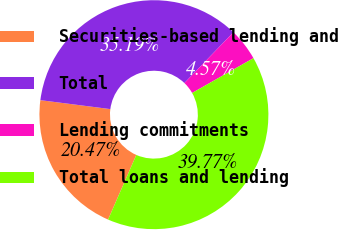Convert chart to OTSL. <chart><loc_0><loc_0><loc_500><loc_500><pie_chart><fcel>Securities-based lending and<fcel>Total<fcel>Lending commitments<fcel>Total loans and lending<nl><fcel>20.47%<fcel>35.19%<fcel>4.57%<fcel>39.77%<nl></chart> 